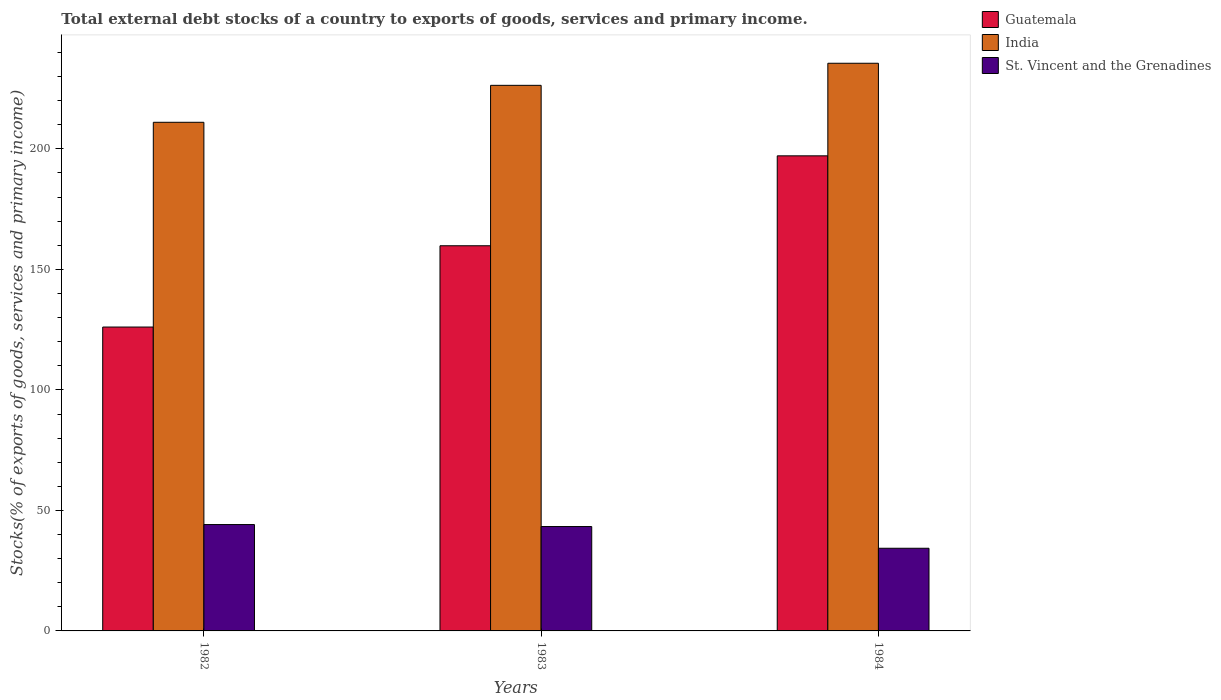Are the number of bars per tick equal to the number of legend labels?
Ensure brevity in your answer.  Yes. Are the number of bars on each tick of the X-axis equal?
Offer a very short reply. Yes. How many bars are there on the 2nd tick from the right?
Make the answer very short. 3. In how many cases, is the number of bars for a given year not equal to the number of legend labels?
Offer a very short reply. 0. What is the total debt stocks in St. Vincent and the Grenadines in 1982?
Ensure brevity in your answer.  44.13. Across all years, what is the maximum total debt stocks in India?
Ensure brevity in your answer.  235.53. Across all years, what is the minimum total debt stocks in St. Vincent and the Grenadines?
Ensure brevity in your answer.  34.3. In which year was the total debt stocks in St. Vincent and the Grenadines maximum?
Give a very brief answer. 1982. In which year was the total debt stocks in St. Vincent and the Grenadines minimum?
Offer a very short reply. 1984. What is the total total debt stocks in Guatemala in the graph?
Ensure brevity in your answer.  483.01. What is the difference between the total debt stocks in Guatemala in 1983 and that in 1984?
Make the answer very short. -37.31. What is the difference between the total debt stocks in Guatemala in 1982 and the total debt stocks in St. Vincent and the Grenadines in 1983?
Offer a very short reply. 82.77. What is the average total debt stocks in Guatemala per year?
Offer a very short reply. 161. In the year 1982, what is the difference between the total debt stocks in Guatemala and total debt stocks in St. Vincent and the Grenadines?
Your response must be concise. 81.95. In how many years, is the total debt stocks in St. Vincent and the Grenadines greater than 70 %?
Offer a terse response. 0. What is the ratio of the total debt stocks in St. Vincent and the Grenadines in 1982 to that in 1983?
Give a very brief answer. 1.02. Is the total debt stocks in Guatemala in 1982 less than that in 1984?
Your answer should be very brief. Yes. What is the difference between the highest and the second highest total debt stocks in Guatemala?
Give a very brief answer. 37.31. What is the difference between the highest and the lowest total debt stocks in St. Vincent and the Grenadines?
Keep it short and to the point. 9.83. Is the sum of the total debt stocks in St. Vincent and the Grenadines in 1982 and 1983 greater than the maximum total debt stocks in India across all years?
Provide a succinct answer. No. What does the 3rd bar from the left in 1982 represents?
Provide a short and direct response. St. Vincent and the Grenadines. What does the 1st bar from the right in 1982 represents?
Provide a short and direct response. St. Vincent and the Grenadines. Is it the case that in every year, the sum of the total debt stocks in St. Vincent and the Grenadines and total debt stocks in India is greater than the total debt stocks in Guatemala?
Ensure brevity in your answer.  Yes. How many years are there in the graph?
Offer a very short reply. 3. What is the difference between two consecutive major ticks on the Y-axis?
Your answer should be compact. 50. Are the values on the major ticks of Y-axis written in scientific E-notation?
Provide a short and direct response. No. Does the graph contain any zero values?
Keep it short and to the point. No. Does the graph contain grids?
Make the answer very short. No. Where does the legend appear in the graph?
Ensure brevity in your answer.  Top right. How many legend labels are there?
Give a very brief answer. 3. How are the legend labels stacked?
Give a very brief answer. Vertical. What is the title of the graph?
Provide a short and direct response. Total external debt stocks of a country to exports of goods, services and primary income. Does "Vietnam" appear as one of the legend labels in the graph?
Provide a succinct answer. No. What is the label or title of the X-axis?
Your answer should be very brief. Years. What is the label or title of the Y-axis?
Your response must be concise. Stocks(% of exports of goods, services and primary income). What is the Stocks(% of exports of goods, services and primary income) of Guatemala in 1982?
Offer a very short reply. 126.08. What is the Stocks(% of exports of goods, services and primary income) of India in 1982?
Provide a succinct answer. 211.04. What is the Stocks(% of exports of goods, services and primary income) in St. Vincent and the Grenadines in 1982?
Provide a succinct answer. 44.13. What is the Stocks(% of exports of goods, services and primary income) of Guatemala in 1983?
Offer a terse response. 159.81. What is the Stocks(% of exports of goods, services and primary income) of India in 1983?
Offer a very short reply. 226.37. What is the Stocks(% of exports of goods, services and primary income) of St. Vincent and the Grenadines in 1983?
Give a very brief answer. 43.31. What is the Stocks(% of exports of goods, services and primary income) of Guatemala in 1984?
Your response must be concise. 197.12. What is the Stocks(% of exports of goods, services and primary income) in India in 1984?
Ensure brevity in your answer.  235.53. What is the Stocks(% of exports of goods, services and primary income) of St. Vincent and the Grenadines in 1984?
Offer a very short reply. 34.3. Across all years, what is the maximum Stocks(% of exports of goods, services and primary income) of Guatemala?
Offer a terse response. 197.12. Across all years, what is the maximum Stocks(% of exports of goods, services and primary income) in India?
Your response must be concise. 235.53. Across all years, what is the maximum Stocks(% of exports of goods, services and primary income) in St. Vincent and the Grenadines?
Your answer should be very brief. 44.13. Across all years, what is the minimum Stocks(% of exports of goods, services and primary income) of Guatemala?
Provide a short and direct response. 126.08. Across all years, what is the minimum Stocks(% of exports of goods, services and primary income) of India?
Your answer should be very brief. 211.04. Across all years, what is the minimum Stocks(% of exports of goods, services and primary income) of St. Vincent and the Grenadines?
Offer a terse response. 34.3. What is the total Stocks(% of exports of goods, services and primary income) of Guatemala in the graph?
Your response must be concise. 483.01. What is the total Stocks(% of exports of goods, services and primary income) of India in the graph?
Offer a very short reply. 672.93. What is the total Stocks(% of exports of goods, services and primary income) of St. Vincent and the Grenadines in the graph?
Provide a succinct answer. 121.74. What is the difference between the Stocks(% of exports of goods, services and primary income) in Guatemala in 1982 and that in 1983?
Ensure brevity in your answer.  -33.73. What is the difference between the Stocks(% of exports of goods, services and primary income) of India in 1982 and that in 1983?
Your answer should be compact. -15.33. What is the difference between the Stocks(% of exports of goods, services and primary income) of St. Vincent and the Grenadines in 1982 and that in 1983?
Ensure brevity in your answer.  0.82. What is the difference between the Stocks(% of exports of goods, services and primary income) in Guatemala in 1982 and that in 1984?
Offer a very short reply. -71.03. What is the difference between the Stocks(% of exports of goods, services and primary income) of India in 1982 and that in 1984?
Provide a succinct answer. -24.49. What is the difference between the Stocks(% of exports of goods, services and primary income) in St. Vincent and the Grenadines in 1982 and that in 1984?
Your answer should be compact. 9.83. What is the difference between the Stocks(% of exports of goods, services and primary income) in Guatemala in 1983 and that in 1984?
Provide a short and direct response. -37.31. What is the difference between the Stocks(% of exports of goods, services and primary income) in India in 1983 and that in 1984?
Keep it short and to the point. -9.16. What is the difference between the Stocks(% of exports of goods, services and primary income) in St. Vincent and the Grenadines in 1983 and that in 1984?
Your answer should be compact. 9.01. What is the difference between the Stocks(% of exports of goods, services and primary income) of Guatemala in 1982 and the Stocks(% of exports of goods, services and primary income) of India in 1983?
Your answer should be compact. -100.28. What is the difference between the Stocks(% of exports of goods, services and primary income) in Guatemala in 1982 and the Stocks(% of exports of goods, services and primary income) in St. Vincent and the Grenadines in 1983?
Your answer should be compact. 82.77. What is the difference between the Stocks(% of exports of goods, services and primary income) of India in 1982 and the Stocks(% of exports of goods, services and primary income) of St. Vincent and the Grenadines in 1983?
Ensure brevity in your answer.  167.73. What is the difference between the Stocks(% of exports of goods, services and primary income) of Guatemala in 1982 and the Stocks(% of exports of goods, services and primary income) of India in 1984?
Your answer should be compact. -109.45. What is the difference between the Stocks(% of exports of goods, services and primary income) in Guatemala in 1982 and the Stocks(% of exports of goods, services and primary income) in St. Vincent and the Grenadines in 1984?
Your answer should be very brief. 91.78. What is the difference between the Stocks(% of exports of goods, services and primary income) in India in 1982 and the Stocks(% of exports of goods, services and primary income) in St. Vincent and the Grenadines in 1984?
Make the answer very short. 176.74. What is the difference between the Stocks(% of exports of goods, services and primary income) in Guatemala in 1983 and the Stocks(% of exports of goods, services and primary income) in India in 1984?
Your answer should be compact. -75.72. What is the difference between the Stocks(% of exports of goods, services and primary income) of Guatemala in 1983 and the Stocks(% of exports of goods, services and primary income) of St. Vincent and the Grenadines in 1984?
Ensure brevity in your answer.  125.51. What is the difference between the Stocks(% of exports of goods, services and primary income) in India in 1983 and the Stocks(% of exports of goods, services and primary income) in St. Vincent and the Grenadines in 1984?
Make the answer very short. 192.07. What is the average Stocks(% of exports of goods, services and primary income) in Guatemala per year?
Your answer should be compact. 161. What is the average Stocks(% of exports of goods, services and primary income) in India per year?
Offer a very short reply. 224.31. What is the average Stocks(% of exports of goods, services and primary income) in St. Vincent and the Grenadines per year?
Ensure brevity in your answer.  40.58. In the year 1982, what is the difference between the Stocks(% of exports of goods, services and primary income) of Guatemala and Stocks(% of exports of goods, services and primary income) of India?
Provide a short and direct response. -84.96. In the year 1982, what is the difference between the Stocks(% of exports of goods, services and primary income) in Guatemala and Stocks(% of exports of goods, services and primary income) in St. Vincent and the Grenadines?
Your answer should be compact. 81.95. In the year 1982, what is the difference between the Stocks(% of exports of goods, services and primary income) of India and Stocks(% of exports of goods, services and primary income) of St. Vincent and the Grenadines?
Your answer should be compact. 166.91. In the year 1983, what is the difference between the Stocks(% of exports of goods, services and primary income) of Guatemala and Stocks(% of exports of goods, services and primary income) of India?
Offer a terse response. -66.56. In the year 1983, what is the difference between the Stocks(% of exports of goods, services and primary income) in Guatemala and Stocks(% of exports of goods, services and primary income) in St. Vincent and the Grenadines?
Your answer should be compact. 116.5. In the year 1983, what is the difference between the Stocks(% of exports of goods, services and primary income) of India and Stocks(% of exports of goods, services and primary income) of St. Vincent and the Grenadines?
Give a very brief answer. 183.06. In the year 1984, what is the difference between the Stocks(% of exports of goods, services and primary income) in Guatemala and Stocks(% of exports of goods, services and primary income) in India?
Give a very brief answer. -38.41. In the year 1984, what is the difference between the Stocks(% of exports of goods, services and primary income) of Guatemala and Stocks(% of exports of goods, services and primary income) of St. Vincent and the Grenadines?
Provide a short and direct response. 162.82. In the year 1984, what is the difference between the Stocks(% of exports of goods, services and primary income) of India and Stocks(% of exports of goods, services and primary income) of St. Vincent and the Grenadines?
Provide a succinct answer. 201.23. What is the ratio of the Stocks(% of exports of goods, services and primary income) of Guatemala in 1982 to that in 1983?
Keep it short and to the point. 0.79. What is the ratio of the Stocks(% of exports of goods, services and primary income) in India in 1982 to that in 1983?
Provide a short and direct response. 0.93. What is the ratio of the Stocks(% of exports of goods, services and primary income) in St. Vincent and the Grenadines in 1982 to that in 1983?
Provide a short and direct response. 1.02. What is the ratio of the Stocks(% of exports of goods, services and primary income) of Guatemala in 1982 to that in 1984?
Make the answer very short. 0.64. What is the ratio of the Stocks(% of exports of goods, services and primary income) of India in 1982 to that in 1984?
Offer a very short reply. 0.9. What is the ratio of the Stocks(% of exports of goods, services and primary income) of St. Vincent and the Grenadines in 1982 to that in 1984?
Keep it short and to the point. 1.29. What is the ratio of the Stocks(% of exports of goods, services and primary income) of Guatemala in 1983 to that in 1984?
Ensure brevity in your answer.  0.81. What is the ratio of the Stocks(% of exports of goods, services and primary income) of India in 1983 to that in 1984?
Provide a short and direct response. 0.96. What is the ratio of the Stocks(% of exports of goods, services and primary income) of St. Vincent and the Grenadines in 1983 to that in 1984?
Your answer should be compact. 1.26. What is the difference between the highest and the second highest Stocks(% of exports of goods, services and primary income) in Guatemala?
Keep it short and to the point. 37.31. What is the difference between the highest and the second highest Stocks(% of exports of goods, services and primary income) in India?
Your answer should be very brief. 9.16. What is the difference between the highest and the second highest Stocks(% of exports of goods, services and primary income) in St. Vincent and the Grenadines?
Your response must be concise. 0.82. What is the difference between the highest and the lowest Stocks(% of exports of goods, services and primary income) of Guatemala?
Make the answer very short. 71.03. What is the difference between the highest and the lowest Stocks(% of exports of goods, services and primary income) of India?
Keep it short and to the point. 24.49. What is the difference between the highest and the lowest Stocks(% of exports of goods, services and primary income) of St. Vincent and the Grenadines?
Ensure brevity in your answer.  9.83. 